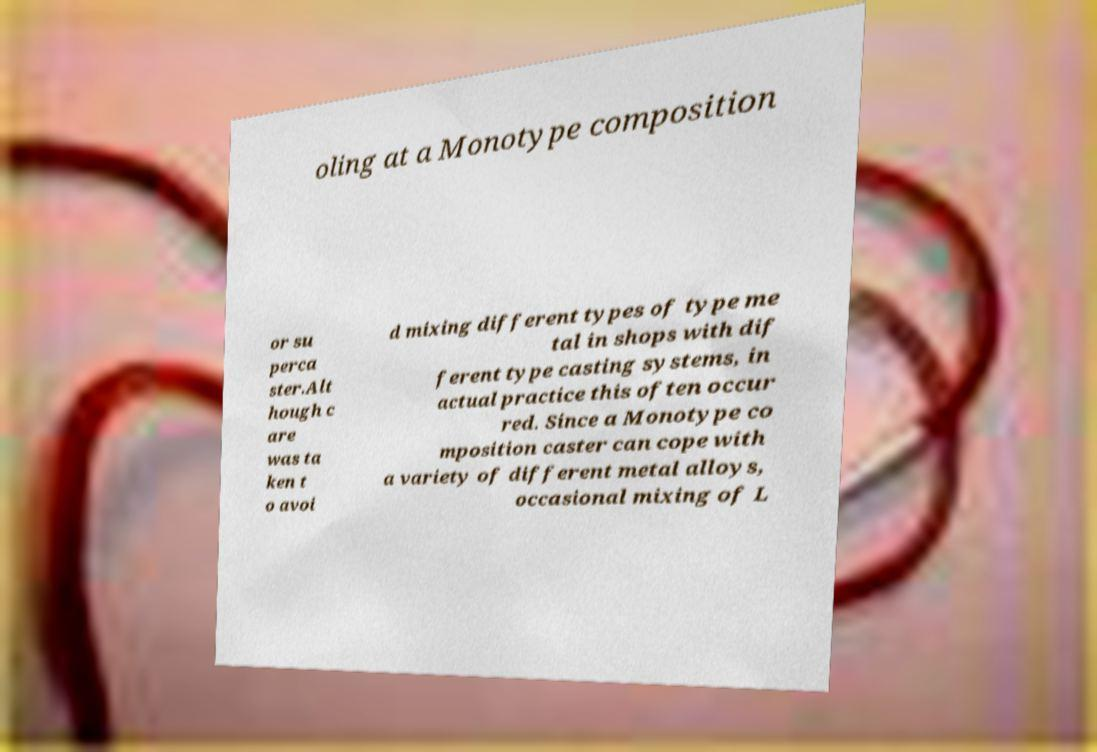Could you assist in decoding the text presented in this image and type it out clearly? oling at a Monotype composition or su perca ster.Alt hough c are was ta ken t o avoi d mixing different types of type me tal in shops with dif ferent type casting systems, in actual practice this often occur red. Since a Monotype co mposition caster can cope with a variety of different metal alloys, occasional mixing of L 